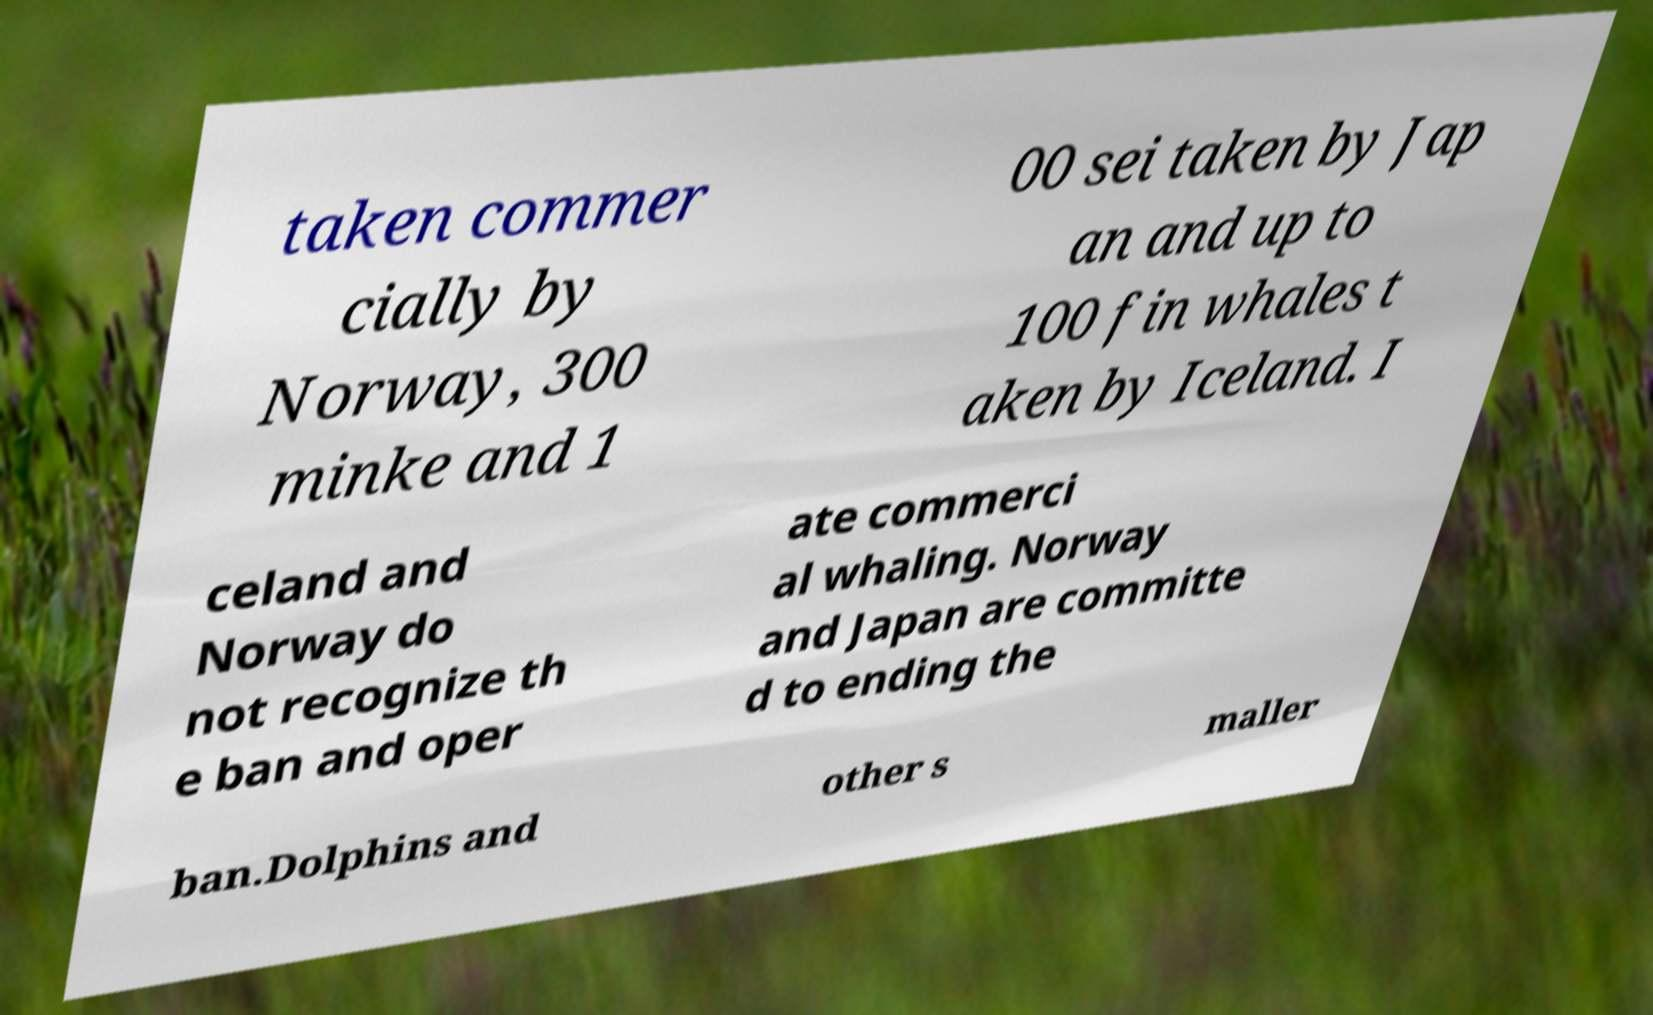Can you accurately transcribe the text from the provided image for me? taken commer cially by Norway, 300 minke and 1 00 sei taken by Jap an and up to 100 fin whales t aken by Iceland. I celand and Norway do not recognize th e ban and oper ate commerci al whaling. Norway and Japan are committe d to ending the ban.Dolphins and other s maller 